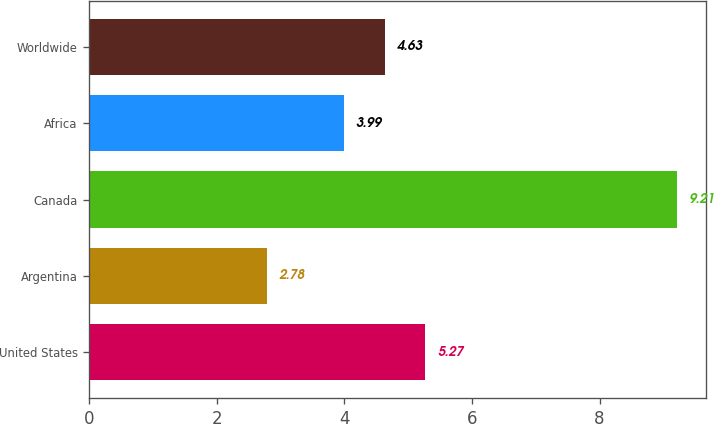<chart> <loc_0><loc_0><loc_500><loc_500><bar_chart><fcel>United States<fcel>Argentina<fcel>Canada<fcel>Africa<fcel>Worldwide<nl><fcel>5.27<fcel>2.78<fcel>9.21<fcel>3.99<fcel>4.63<nl></chart> 